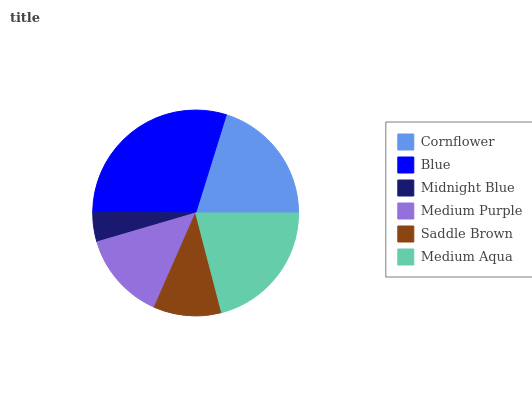Is Midnight Blue the minimum?
Answer yes or no. Yes. Is Blue the maximum?
Answer yes or no. Yes. Is Blue the minimum?
Answer yes or no. No. Is Midnight Blue the maximum?
Answer yes or no. No. Is Blue greater than Midnight Blue?
Answer yes or no. Yes. Is Midnight Blue less than Blue?
Answer yes or no. Yes. Is Midnight Blue greater than Blue?
Answer yes or no. No. Is Blue less than Midnight Blue?
Answer yes or no. No. Is Cornflower the high median?
Answer yes or no. Yes. Is Medium Purple the low median?
Answer yes or no. Yes. Is Blue the high median?
Answer yes or no. No. Is Midnight Blue the low median?
Answer yes or no. No. 